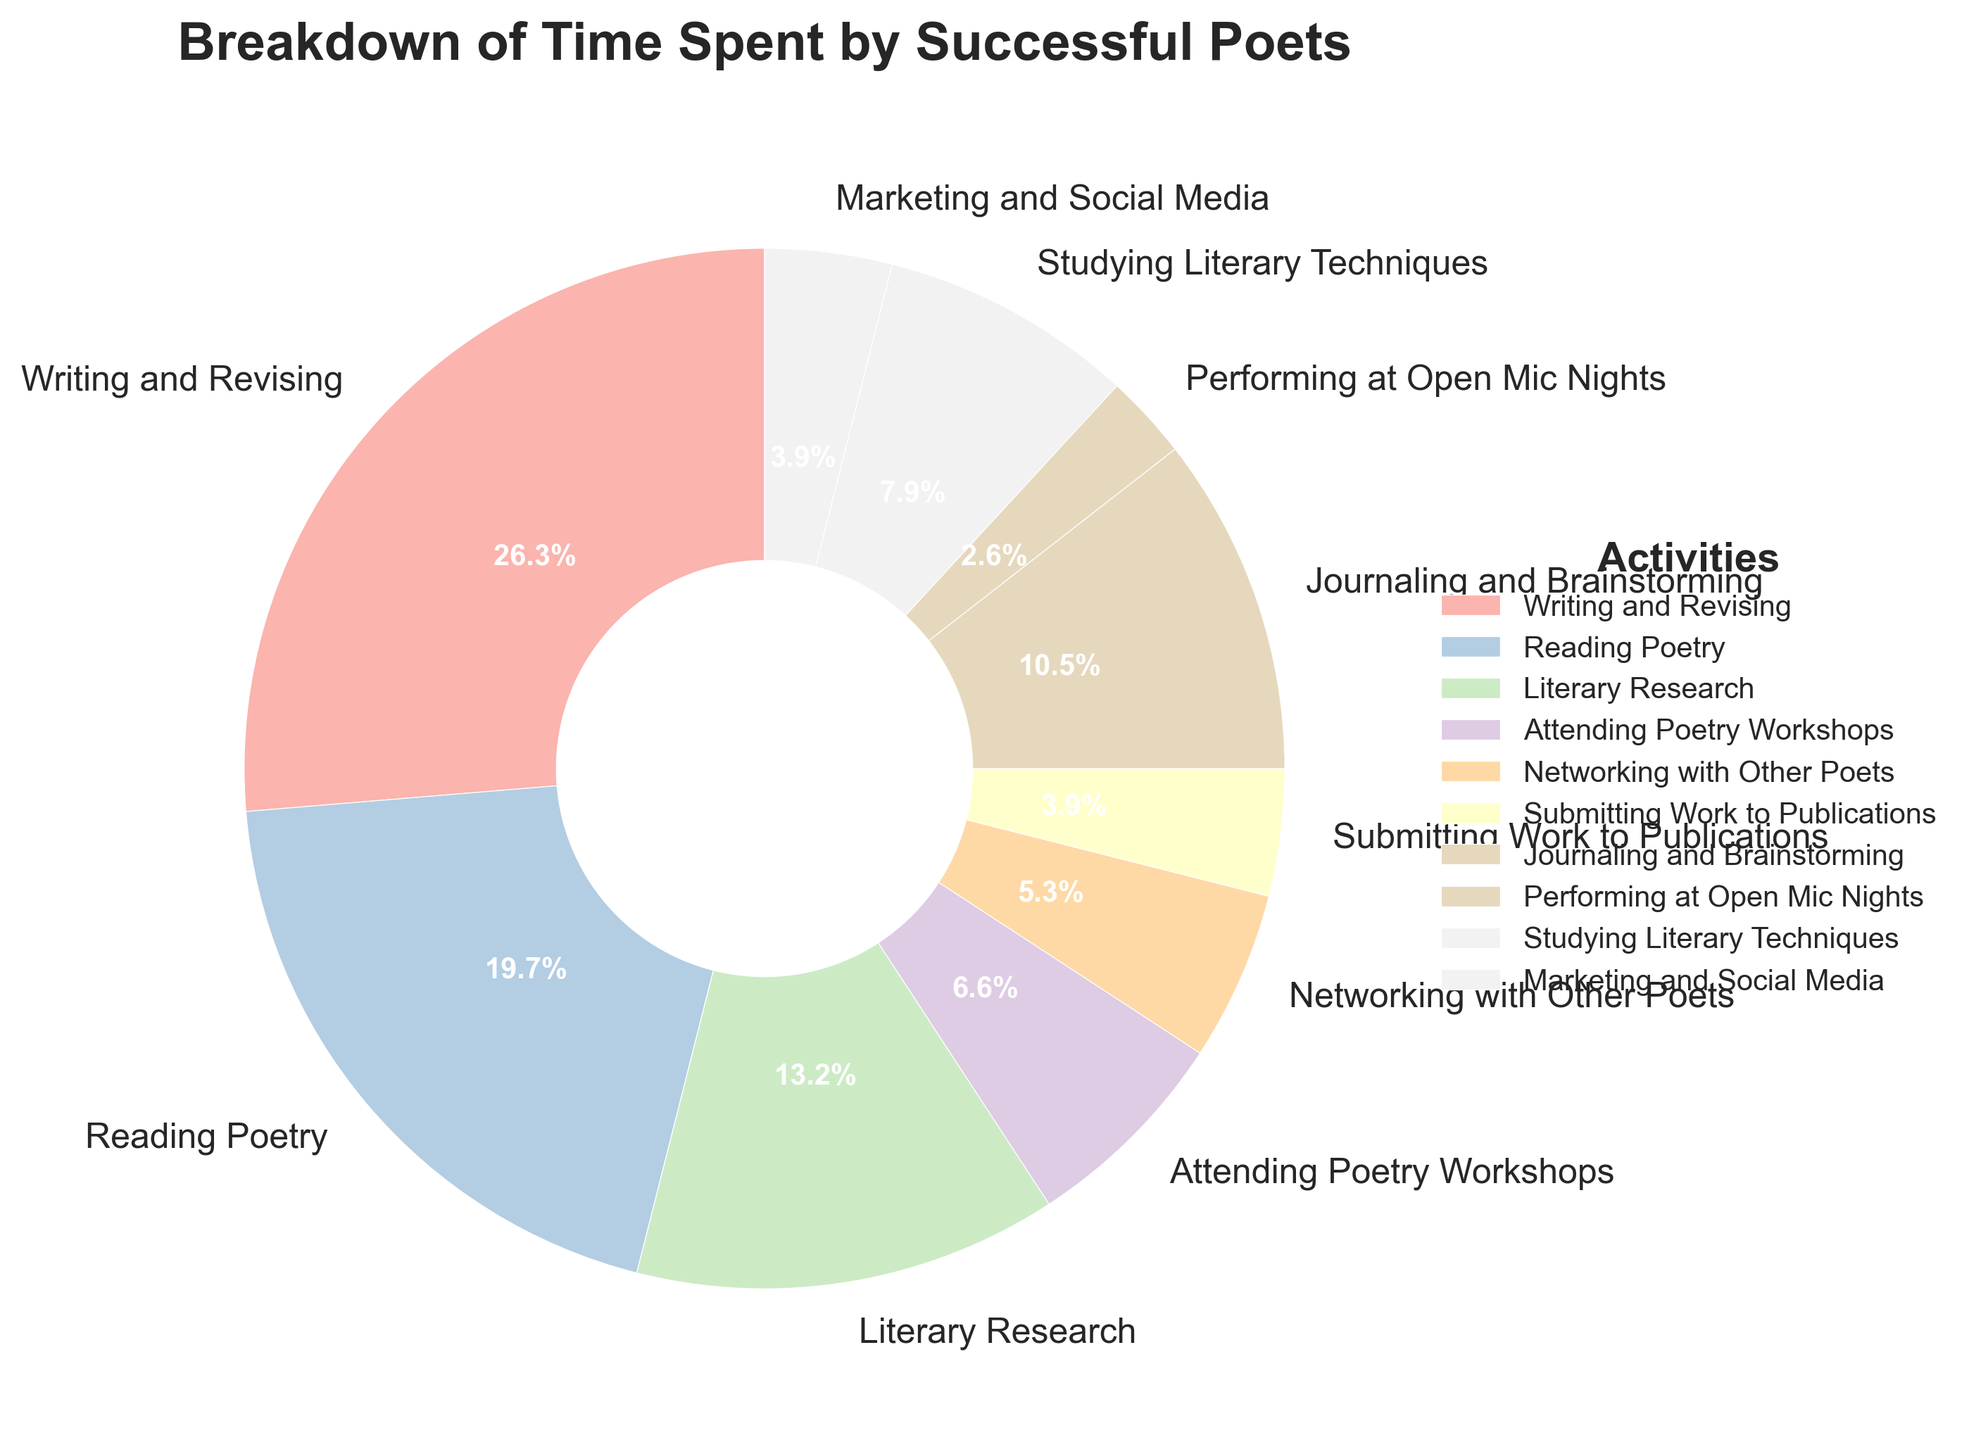What activity takes up the largest portion of time for successful poets? By observing the pie chart, we see which activity has the biggest slice. The largest segment represents "Writing and Revising".
Answer: Writing and Revising Which two activities have the same amount of time dedicated to them? By comparing the sizes of the slices, we find that "Submitting Work to Publications" and "Marketing and Social Media" occupy the same size segment.
Answer: Submitting Work to Publications and Marketing and Social Media How much total time is spent on activities related to reading and researching? Summing up the hours from "Reading Poetry" and "Literary Research", we get 15 hours + 10 hours.
Answer: 25 hours Which activity takes the least amount of time and what percentage does it represent? By looking for the smallest slice in the pie chart, we find "Performing at Open Mic Nights", and its percentage is labeled on the segment.
Answer: Performing at Open Mic Nights, 2.3% Is more time spent on "Writing and Revising" or on "Reading Poetry" and "Journaling and Brainstorming" combined? By summing "Reading Poetry" and "Journaling and Brainstorming" (15 + 8 = 23 hours) and comparing it to "Writing and Revising" (20 hours), we see that 23 hours is more than 20 hours.
Answer: Reading Poetry and Journaling and Brainstorming How much more time is spent on "Writing and Revising" than "Attending Poetry Workshops"? Subtracting the hours for "Attending Poetry Workshops" from "Writing and Revising" (20 - 5 = 15 hours).
Answer: 15 hours Which three activities together make up just over one-quarter of the total time? By checking the percentages, "Literary Research" (11.6%), "Journaling and Brainstorming" (9.3%), and "Studying Literary Techniques" (7%) together sum to approximately 27.9%.
Answer: Literary Research, Journaling and Brainstorming, Studying Literary Techniques How many hours less are spent on "Networking with Other Poets" than on "Studying Literary Techniques"? "Studying Literary Techniques" is 6 hours and "Networking with Other Poets" is 4 hours, so the difference is 6 - 4.
Answer: 2 hours Which activity's slice has a distinct color that stands out visually the most? Observing the pie chart’s colors, we note the slice with the most contrasting color compared to others. A subjective evaluation might be required.
Answer: (Observation-based, e.g., perhaps "Writing and Revising" if it has a distinct color) If the total week has 60 hours dedicated to these activities, what percentage of time is allocated to "Reading Poetry"? "Reading Poetry" gets 15 hours. So the percentage is (15/60) * 100.
Answer: 25% 